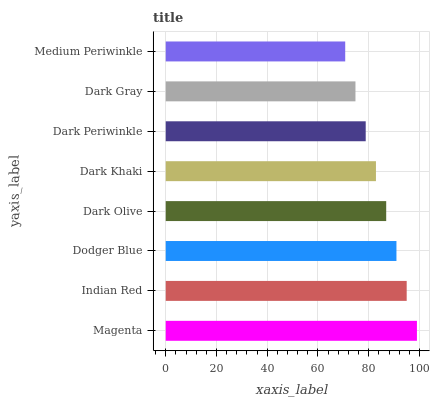Is Medium Periwinkle the minimum?
Answer yes or no. Yes. Is Magenta the maximum?
Answer yes or no. Yes. Is Indian Red the minimum?
Answer yes or no. No. Is Indian Red the maximum?
Answer yes or no. No. Is Magenta greater than Indian Red?
Answer yes or no. Yes. Is Indian Red less than Magenta?
Answer yes or no. Yes. Is Indian Red greater than Magenta?
Answer yes or no. No. Is Magenta less than Indian Red?
Answer yes or no. No. Is Dark Olive the high median?
Answer yes or no. Yes. Is Dark Khaki the low median?
Answer yes or no. Yes. Is Dark Periwinkle the high median?
Answer yes or no. No. Is Dark Gray the low median?
Answer yes or no. No. 